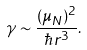<formula> <loc_0><loc_0><loc_500><loc_500>\gamma \sim \frac { ( \mu _ { N } ) ^ { 2 } } { \hbar { r } ^ { 3 } } .</formula> 